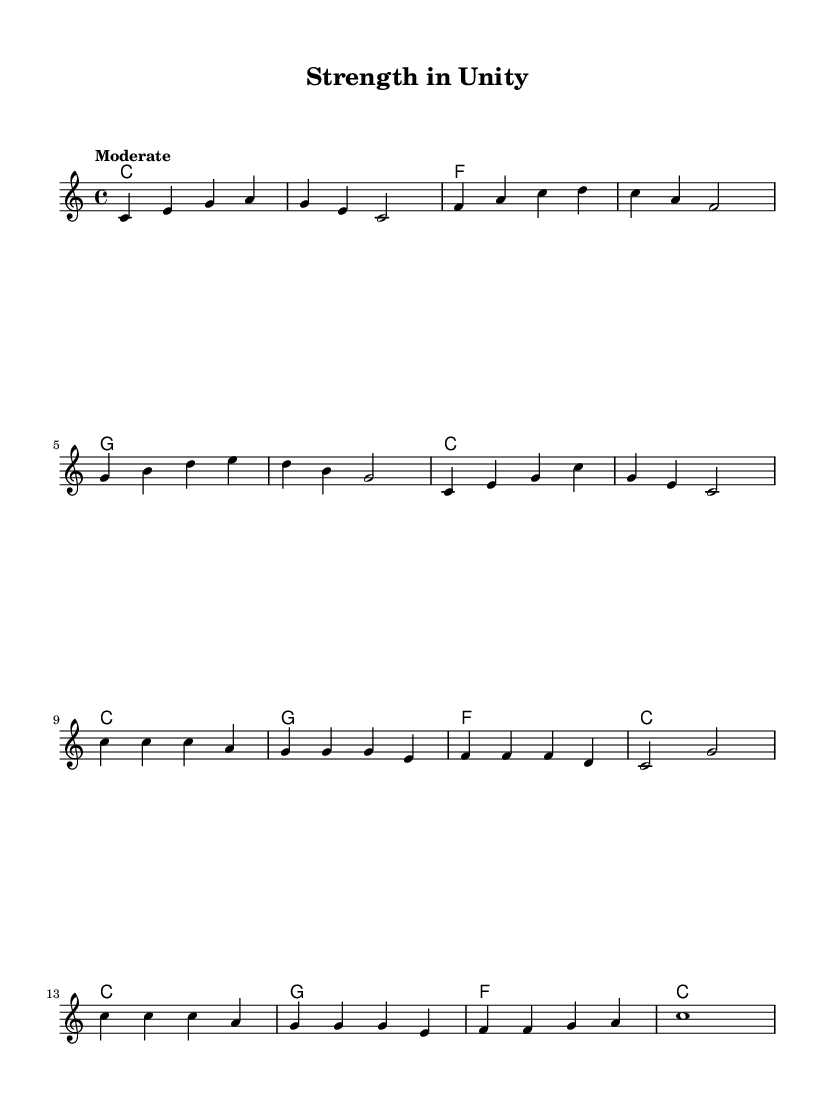What is the key signature of this music? The key signature is C major since there are no sharps or flats indicated in the staff.
Answer: C major What is the time signature of this music? The time signature is shown at the beginning of the score as 4/4, meaning there are four beats in each measure and the quarter note gets one beat.
Answer: 4/4 What is the tempo marking for this piece? The tempo marking is "Moderate," which describes the pace at which the piece should be played.
Answer: Moderate How many measures are in the verse section? By counting the measures in the melody for the verse, there are a total of eight measures.
Answer: 8 Which chord is introduced in the chorus for the first time? The chorus includes a G chord that does not appear in the verse, hence the first introduction in the chorus.
Answer: G What is the last note of the melody? The melody concludes with the note C, indicating the final tone of the composition.
Answer: C What musical form does this piece primarily follow? The piece follows a verse-chorus form, alternating between two distinct sections that highlight the theme.
Answer: Verse-Chorus 